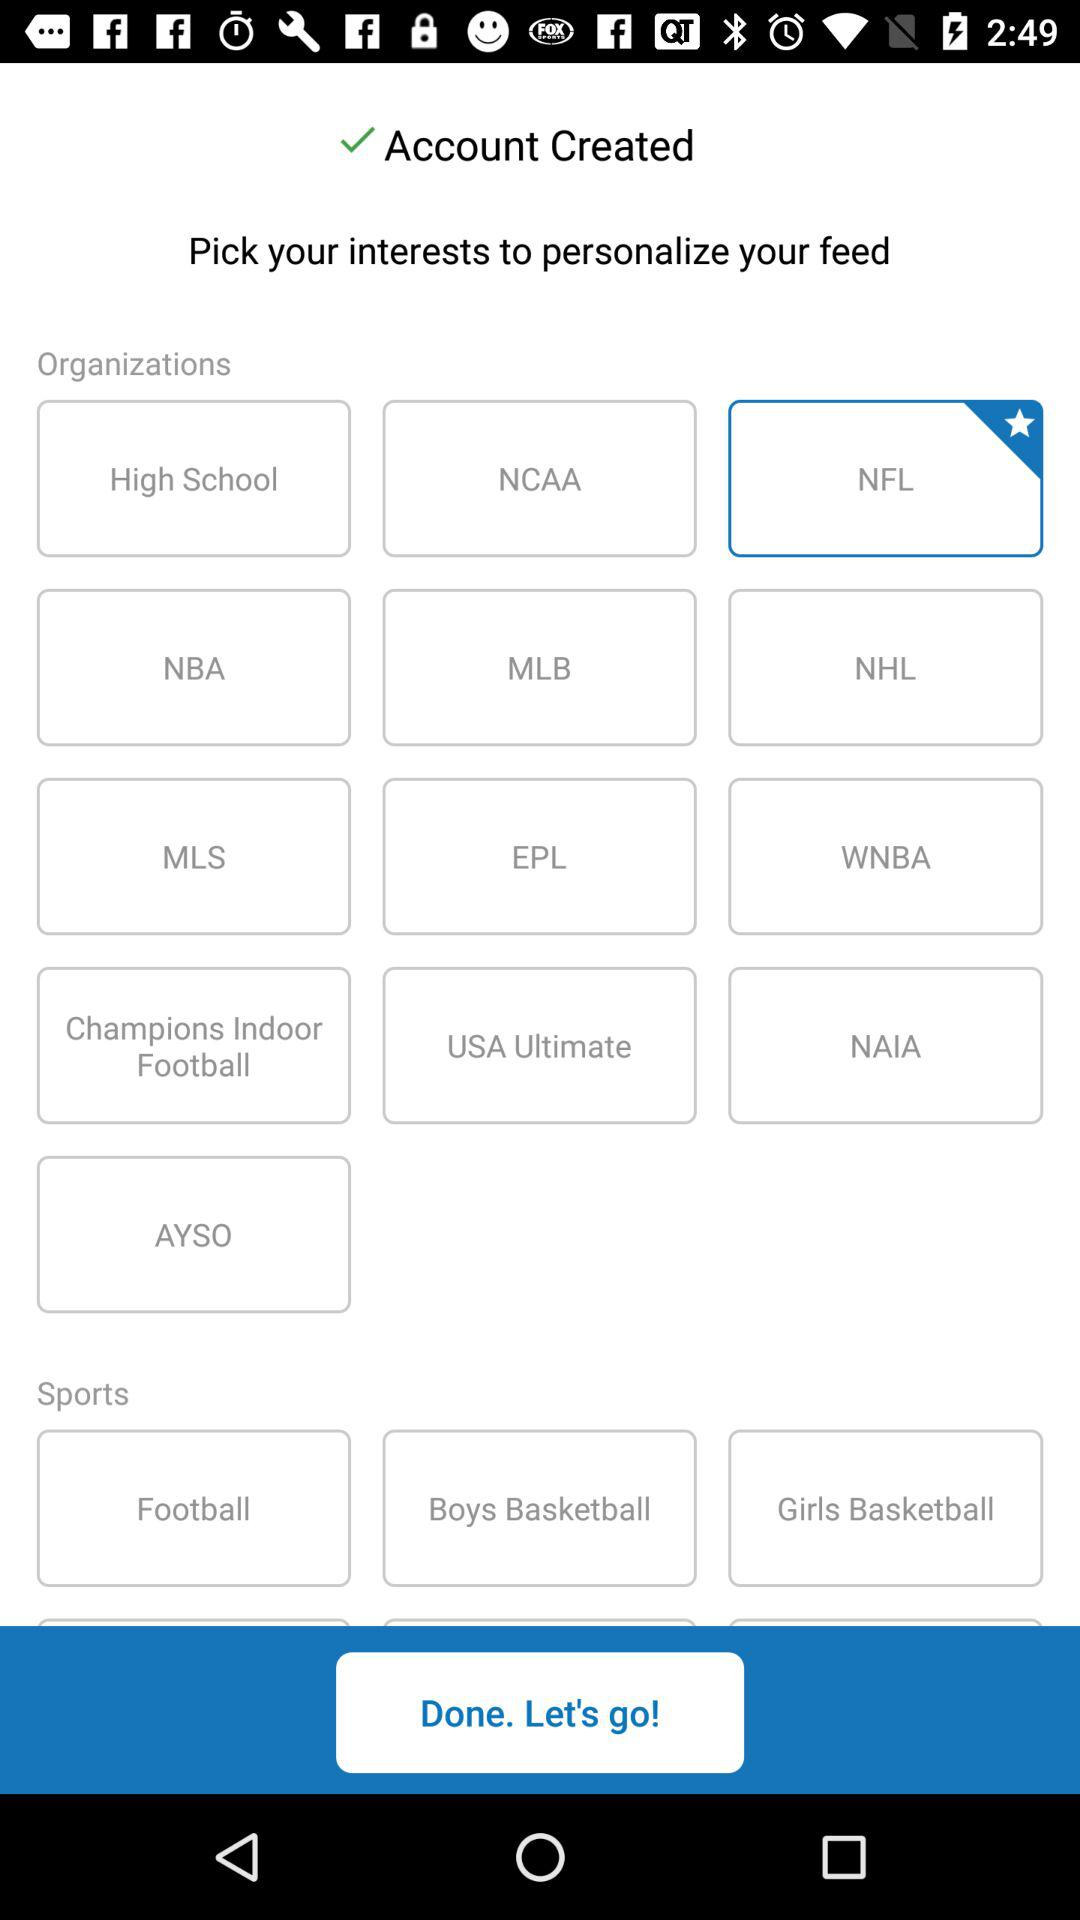What options are available for sports? The options are football, boys' basketball and girls' basketball. 